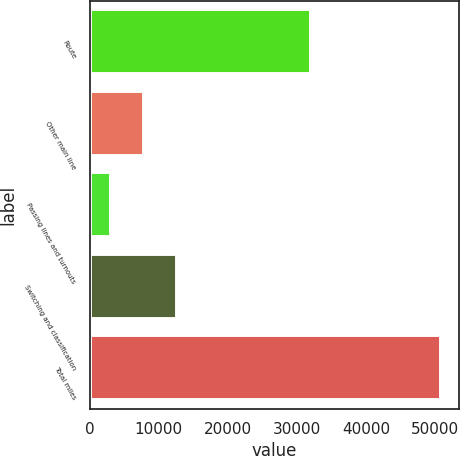<chart> <loc_0><loc_0><loc_500><loc_500><bar_chart><fcel>Route<fcel>Other main line<fcel>Passing lines and turnouts<fcel>Switching and classification<fcel>Total miles<nl><fcel>32094<fcel>7824.5<fcel>3040<fcel>12609<fcel>50885<nl></chart> 